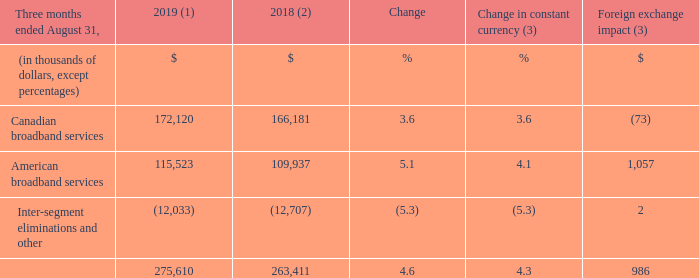ADJUSTED EBITDA
(1) For the three-month period ended August 31, 2019, the average foreign exchange rate used for translation was 1.3222 USD/CDN.
(2) Fiscal 2018 was restated to comply with IFRS 15 and to reflect a change in accounting policy as well as to reclassify results from Cogeco Peer 1 as discontinued operations. For further details, please consult the "Accounting policies" and "Discontinued operations" sections.
(3) Fiscal 2019 actuals are translated at the average foreign exchange rate of the comparable period of fiscal 2018 which was 1.3100 USD/CDN.
Fiscal 2019 fourth-quarter adjusted EBITDA increased by 4.6% (4.3% in constant currency) as a result of: • an increase in the American broadband services segment mainly as a result of strong organic growth combined with the impact of the FiberLight acquisition; and • an increase in the Canadian broadband services segment resulting mainly from a decline in operating expenses.
What was the exchange rate in 2019? 1.3222 usd/cdn. What was the exchange rate in 2018? 1.3100 usd/cdn. What was the increase in EBITDA in fourth-quarter 2019? 4.6%. What is the increase / (decrease) in the Canadian broadband services from 2018 to 2019?
Answer scale should be: thousand. 172,120 - 166,181
Answer: 5939. What was the average Canadian broadband services?
Answer scale should be: thousand. (172,120 + 166,181) / 2
Answer: 169150.5. What was the average American broadband services from 2018 to 2019?
Answer scale should be: thousand. (115,523 + 109,937) / 2
Answer: 112730. 